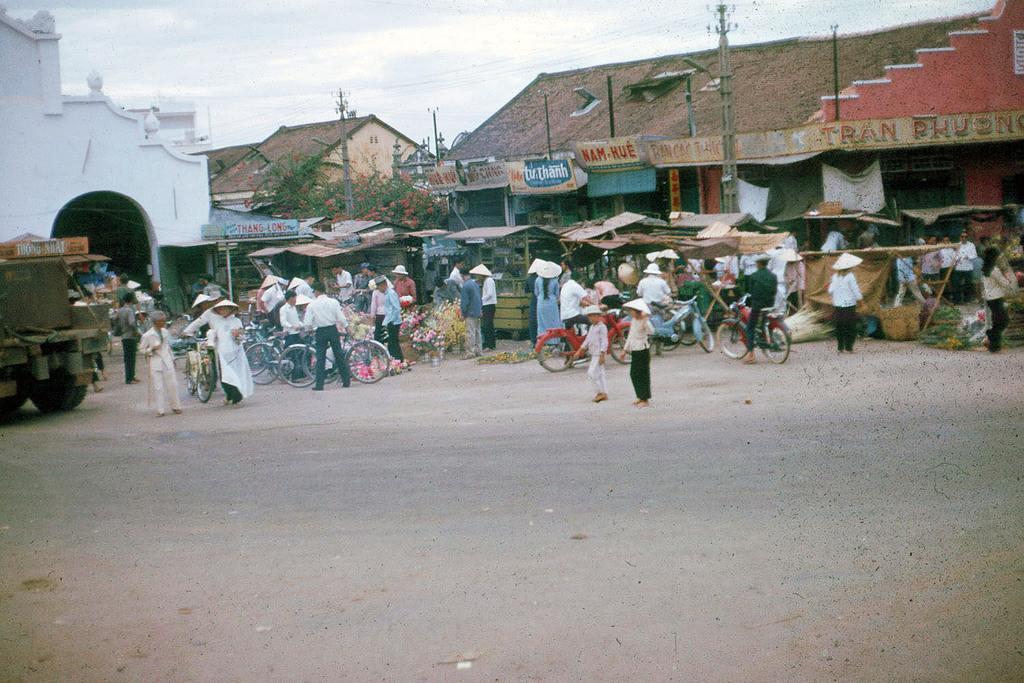In one or two sentences, can you explain what this image depicts? This picture is clicked outside. In the center we can see the group of persons and we can see the tents, vehicle, group of person riding bicycles and we can see the flowers and many other objects placed on the ground. In the background we can see the sky, cables, poles and some houses and we can see the texts on the boards attached to the houses. 